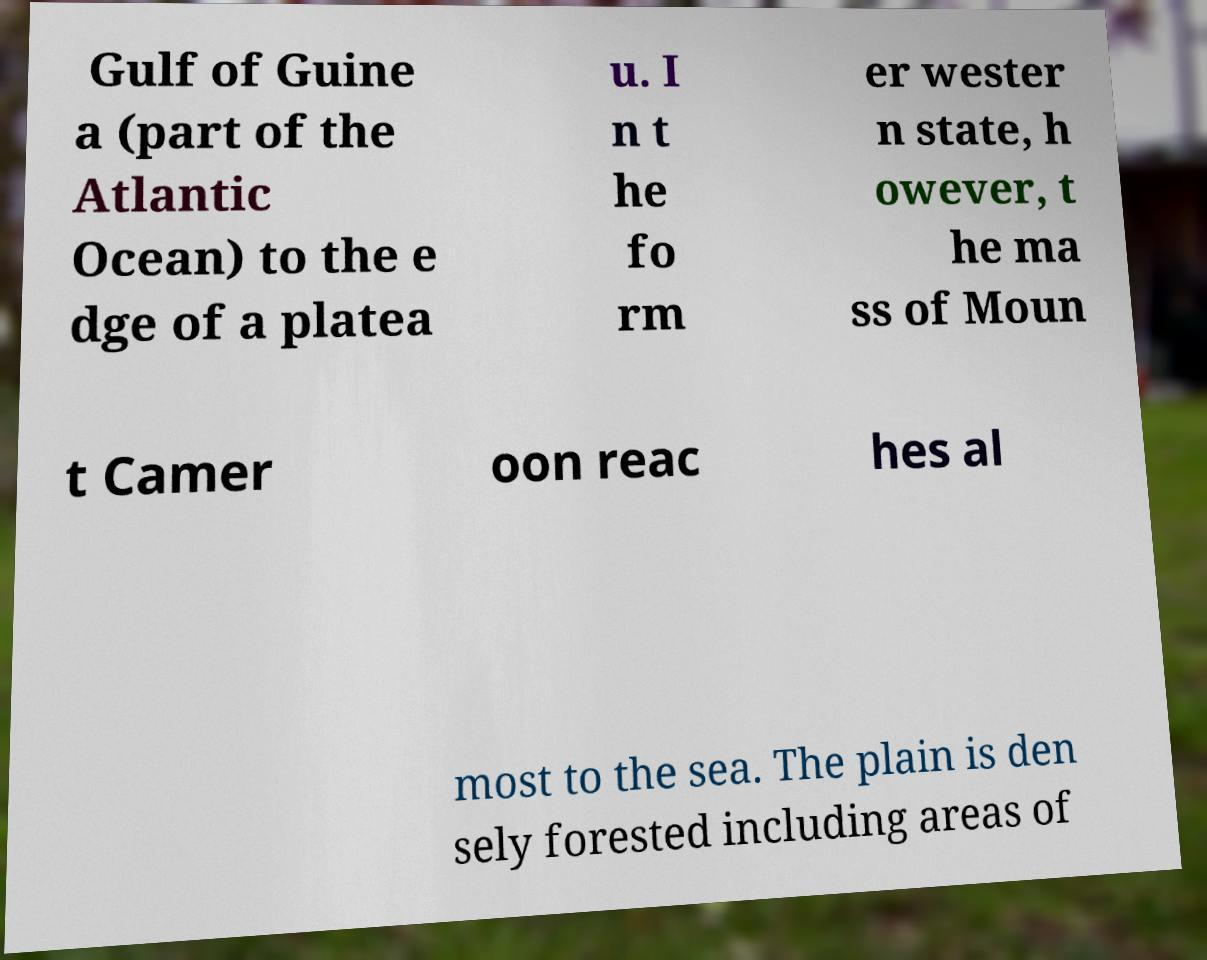Could you assist in decoding the text presented in this image and type it out clearly? Gulf of Guine a (part of the Atlantic Ocean) to the e dge of a platea u. I n t he fo rm er wester n state, h owever, t he ma ss of Moun t Camer oon reac hes al most to the sea. The plain is den sely forested including areas of 